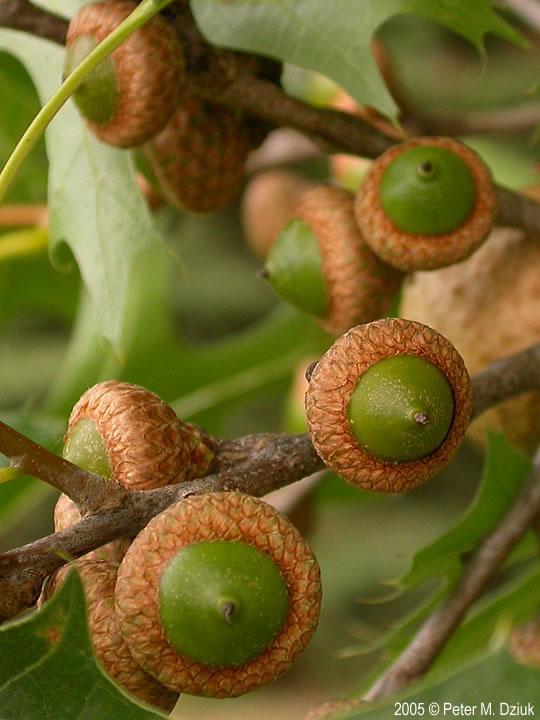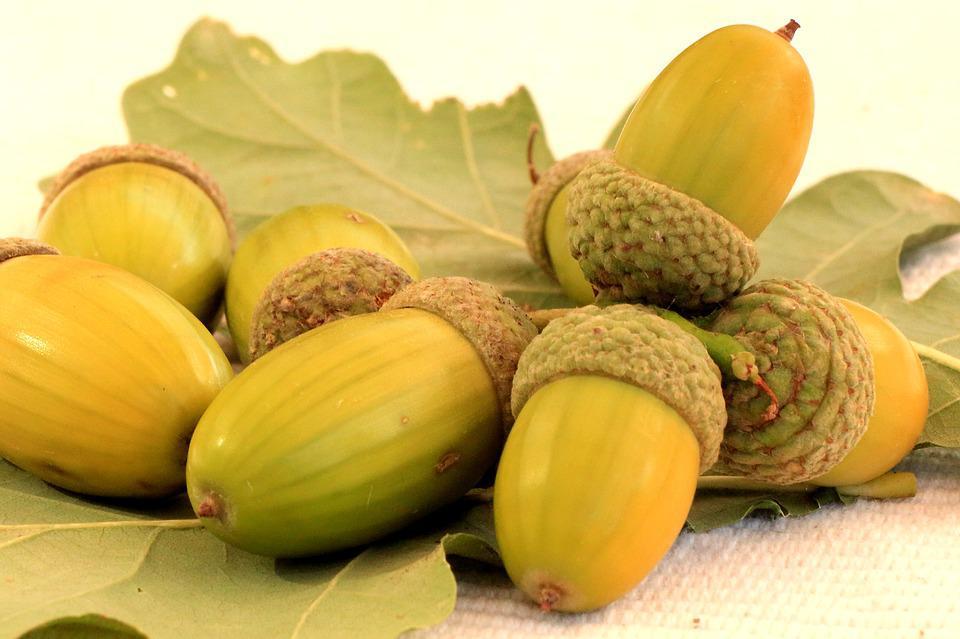The first image is the image on the left, the second image is the image on the right. Evaluate the accuracy of this statement regarding the images: "The right image features exactly two green-skinned acorns with their green caps back-to-back.". Is it true? Answer yes or no. No. The first image is the image on the left, the second image is the image on the right. Evaluate the accuracy of this statement regarding the images: "There are two green acorns and green acorn tops still attach to each other". Is it true? Answer yes or no. No. 